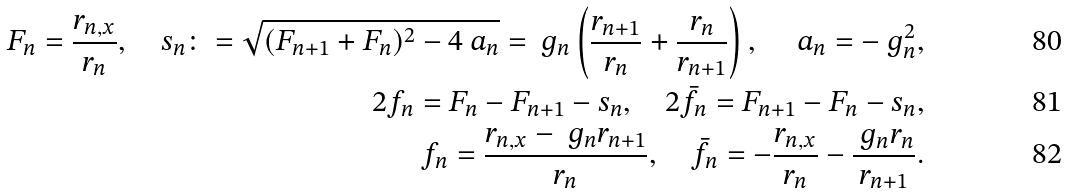<formula> <loc_0><loc_0><loc_500><loc_500>F _ { n } = \frac { r _ { n , x } } { r _ { n } } , \quad s _ { n } \colon = \sqrt { ( F _ { n + 1 } + F _ { n } ) ^ { 2 } - 4 \ a _ { n } } = \ g _ { n } \left ( \frac { r _ { n + 1 } } { r _ { n } } + \frac { r _ { n } } { r _ { n + 1 } } \right ) , \quad \ a _ { n } = - \ g ^ { 2 } _ { n } , \\ 2 f _ { n } = F _ { n } - F _ { n + 1 } - s _ { n } , \quad 2 \bar { f } _ { n } = F _ { n + 1 } - F _ { n } - s _ { n } , \\ f _ { n } = \frac { r _ { n , x } - \ g _ { n } r _ { n + 1 } } { r _ { n } } , \quad \bar { f } _ { n } = - \frac { r _ { n , x } } { r _ { n } } - \frac { \ g _ { n } r _ { n } } { r _ { n + 1 } } .</formula> 